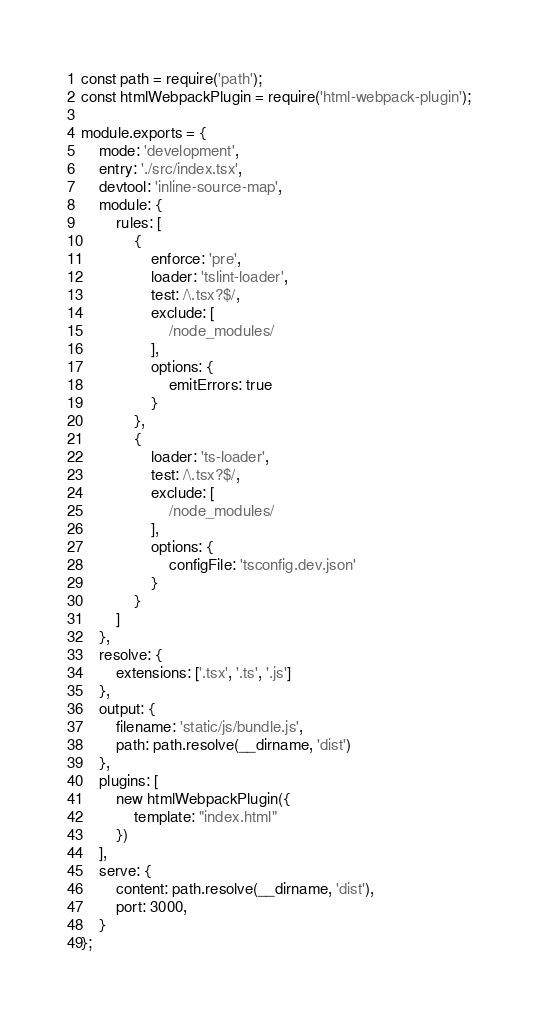Convert code to text. <code><loc_0><loc_0><loc_500><loc_500><_JavaScript_>const path = require('path');
const htmlWebpackPlugin = require('html-webpack-plugin');

module.exports = {
    mode: 'development',
    entry: './src/index.tsx',
    devtool: 'inline-source-map',
    module: {
        rules: [
            {
                enforce: 'pre',
                loader: 'tslint-loader',
                test: /\.tsx?$/,
                exclude: [
                    /node_modules/
                ],
                options: {
                    emitErrors: true
                }
            },
            {
                loader: 'ts-loader',
                test: /\.tsx?$/,
                exclude: [
                    /node_modules/
                ],
                options: {
                    configFile: 'tsconfig.dev.json'
                }
            }
        ]
    },
    resolve: {
        extensions: ['.tsx', '.ts', '.js']
    },
    output: {
        filename: 'static/js/bundle.js',
        path: path.resolve(__dirname, 'dist')
    },
    plugins: [
        new htmlWebpackPlugin({
            template: "index.html"
        })
    ],
    serve: {
        content: path.resolve(__dirname, 'dist'),
        port: 3000,
    }
};</code> 